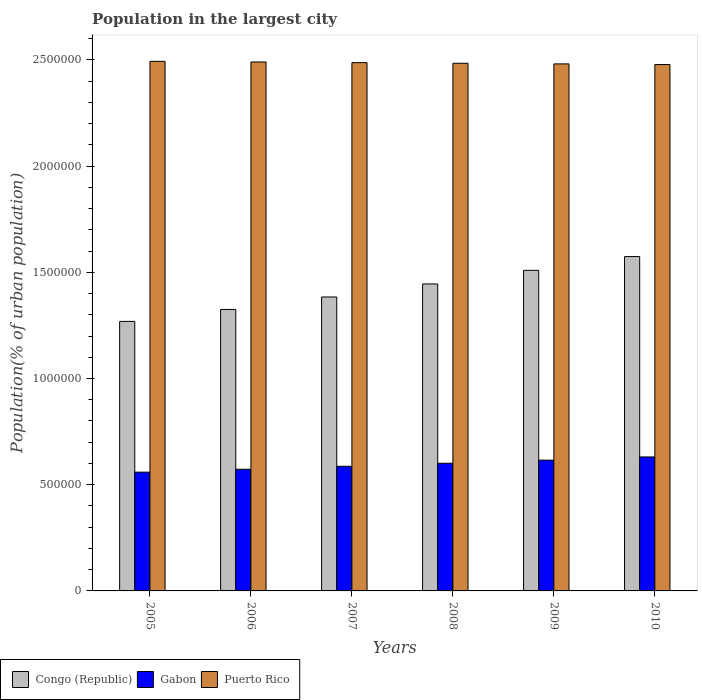How many different coloured bars are there?
Provide a succinct answer. 3. Are the number of bars on each tick of the X-axis equal?
Offer a very short reply. Yes. How many bars are there on the 3rd tick from the right?
Give a very brief answer. 3. In how many cases, is the number of bars for a given year not equal to the number of legend labels?
Ensure brevity in your answer.  0. What is the population in the largest city in Gabon in 2009?
Offer a very short reply. 6.16e+05. Across all years, what is the maximum population in the largest city in Congo (Republic)?
Your response must be concise. 1.57e+06. Across all years, what is the minimum population in the largest city in Congo (Republic)?
Provide a short and direct response. 1.27e+06. What is the total population in the largest city in Gabon in the graph?
Offer a terse response. 3.57e+06. What is the difference between the population in the largest city in Gabon in 2009 and that in 2010?
Your answer should be compact. -1.50e+04. What is the difference between the population in the largest city in Gabon in 2005 and the population in the largest city in Congo (Republic) in 2006?
Your answer should be compact. -7.66e+05. What is the average population in the largest city in Gabon per year?
Provide a succinct answer. 5.94e+05. In the year 2008, what is the difference between the population in the largest city in Gabon and population in the largest city in Congo (Republic)?
Ensure brevity in your answer.  -8.44e+05. What is the ratio of the population in the largest city in Gabon in 2005 to that in 2009?
Ensure brevity in your answer.  0.91. Is the difference between the population in the largest city in Gabon in 2007 and 2009 greater than the difference between the population in the largest city in Congo (Republic) in 2007 and 2009?
Provide a short and direct response. Yes. What is the difference between the highest and the second highest population in the largest city in Congo (Republic)?
Offer a very short reply. 6.49e+04. What is the difference between the highest and the lowest population in the largest city in Congo (Republic)?
Your answer should be very brief. 3.05e+05. What does the 3rd bar from the left in 2005 represents?
Offer a terse response. Puerto Rico. What does the 1st bar from the right in 2009 represents?
Offer a terse response. Puerto Rico. Is it the case that in every year, the sum of the population in the largest city in Congo (Republic) and population in the largest city in Puerto Rico is greater than the population in the largest city in Gabon?
Keep it short and to the point. Yes. Are all the bars in the graph horizontal?
Offer a terse response. No. What is the difference between two consecutive major ticks on the Y-axis?
Offer a very short reply. 5.00e+05. Are the values on the major ticks of Y-axis written in scientific E-notation?
Ensure brevity in your answer.  No. How are the legend labels stacked?
Give a very brief answer. Horizontal. What is the title of the graph?
Your answer should be compact. Population in the largest city. Does "Timor-Leste" appear as one of the legend labels in the graph?
Provide a short and direct response. No. What is the label or title of the X-axis?
Your answer should be compact. Years. What is the label or title of the Y-axis?
Give a very brief answer. Population(% of urban population). What is the Population(% of urban population) of Congo (Republic) in 2005?
Ensure brevity in your answer.  1.27e+06. What is the Population(% of urban population) in Gabon in 2005?
Make the answer very short. 5.59e+05. What is the Population(% of urban population) of Puerto Rico in 2005?
Your answer should be compact. 2.49e+06. What is the Population(% of urban population) in Congo (Republic) in 2006?
Give a very brief answer. 1.33e+06. What is the Population(% of urban population) in Gabon in 2006?
Offer a very short reply. 5.73e+05. What is the Population(% of urban population) in Puerto Rico in 2006?
Make the answer very short. 2.49e+06. What is the Population(% of urban population) of Congo (Republic) in 2007?
Make the answer very short. 1.38e+06. What is the Population(% of urban population) of Gabon in 2007?
Your response must be concise. 5.87e+05. What is the Population(% of urban population) in Puerto Rico in 2007?
Offer a terse response. 2.49e+06. What is the Population(% of urban population) in Congo (Republic) in 2008?
Make the answer very short. 1.45e+06. What is the Population(% of urban population) of Gabon in 2008?
Your answer should be compact. 6.01e+05. What is the Population(% of urban population) of Puerto Rico in 2008?
Your response must be concise. 2.48e+06. What is the Population(% of urban population) of Congo (Republic) in 2009?
Your answer should be very brief. 1.51e+06. What is the Population(% of urban population) of Gabon in 2009?
Your response must be concise. 6.16e+05. What is the Population(% of urban population) of Puerto Rico in 2009?
Make the answer very short. 2.48e+06. What is the Population(% of urban population) of Congo (Republic) in 2010?
Ensure brevity in your answer.  1.57e+06. What is the Population(% of urban population) of Gabon in 2010?
Give a very brief answer. 6.31e+05. What is the Population(% of urban population) of Puerto Rico in 2010?
Keep it short and to the point. 2.48e+06. Across all years, what is the maximum Population(% of urban population) in Congo (Republic)?
Provide a succinct answer. 1.57e+06. Across all years, what is the maximum Population(% of urban population) in Gabon?
Your response must be concise. 6.31e+05. Across all years, what is the maximum Population(% of urban population) of Puerto Rico?
Your answer should be very brief. 2.49e+06. Across all years, what is the minimum Population(% of urban population) in Congo (Republic)?
Ensure brevity in your answer.  1.27e+06. Across all years, what is the minimum Population(% of urban population) of Gabon?
Offer a terse response. 5.59e+05. Across all years, what is the minimum Population(% of urban population) in Puerto Rico?
Provide a short and direct response. 2.48e+06. What is the total Population(% of urban population) of Congo (Republic) in the graph?
Your answer should be compact. 8.51e+06. What is the total Population(% of urban population) in Gabon in the graph?
Offer a terse response. 3.57e+06. What is the total Population(% of urban population) of Puerto Rico in the graph?
Your answer should be very brief. 1.49e+07. What is the difference between the Population(% of urban population) of Congo (Republic) in 2005 and that in 2006?
Keep it short and to the point. -5.62e+04. What is the difference between the Population(% of urban population) in Gabon in 2005 and that in 2006?
Offer a terse response. -1.36e+04. What is the difference between the Population(% of urban population) of Puerto Rico in 2005 and that in 2006?
Give a very brief answer. 3008. What is the difference between the Population(% of urban population) of Congo (Republic) in 2005 and that in 2007?
Offer a terse response. -1.15e+05. What is the difference between the Population(% of urban population) in Gabon in 2005 and that in 2007?
Provide a succinct answer. -2.76e+04. What is the difference between the Population(% of urban population) in Puerto Rico in 2005 and that in 2007?
Ensure brevity in your answer.  6012. What is the difference between the Population(% of urban population) of Congo (Republic) in 2005 and that in 2008?
Provide a succinct answer. -1.76e+05. What is the difference between the Population(% of urban population) of Gabon in 2005 and that in 2008?
Provide a succinct answer. -4.19e+04. What is the difference between the Population(% of urban population) of Puerto Rico in 2005 and that in 2008?
Provide a succinct answer. 9017. What is the difference between the Population(% of urban population) of Congo (Republic) in 2005 and that in 2009?
Give a very brief answer. -2.40e+05. What is the difference between the Population(% of urban population) in Gabon in 2005 and that in 2009?
Provide a succinct answer. -5.66e+04. What is the difference between the Population(% of urban population) in Puerto Rico in 2005 and that in 2009?
Your response must be concise. 1.20e+04. What is the difference between the Population(% of urban population) in Congo (Republic) in 2005 and that in 2010?
Ensure brevity in your answer.  -3.05e+05. What is the difference between the Population(% of urban population) in Gabon in 2005 and that in 2010?
Your response must be concise. -7.16e+04. What is the difference between the Population(% of urban population) of Puerto Rico in 2005 and that in 2010?
Ensure brevity in your answer.  1.50e+04. What is the difference between the Population(% of urban population) in Congo (Republic) in 2006 and that in 2007?
Keep it short and to the point. -5.87e+04. What is the difference between the Population(% of urban population) in Gabon in 2006 and that in 2007?
Your response must be concise. -1.40e+04. What is the difference between the Population(% of urban population) of Puerto Rico in 2006 and that in 2007?
Offer a terse response. 3004. What is the difference between the Population(% of urban population) in Congo (Republic) in 2006 and that in 2008?
Your answer should be compact. -1.20e+05. What is the difference between the Population(% of urban population) of Gabon in 2006 and that in 2008?
Make the answer very short. -2.83e+04. What is the difference between the Population(% of urban population) in Puerto Rico in 2006 and that in 2008?
Your answer should be very brief. 6009. What is the difference between the Population(% of urban population) in Congo (Republic) in 2006 and that in 2009?
Offer a terse response. -1.84e+05. What is the difference between the Population(% of urban population) of Gabon in 2006 and that in 2009?
Offer a very short reply. -4.30e+04. What is the difference between the Population(% of urban population) in Puerto Rico in 2006 and that in 2009?
Offer a very short reply. 9002. What is the difference between the Population(% of urban population) in Congo (Republic) in 2006 and that in 2010?
Your answer should be compact. -2.49e+05. What is the difference between the Population(% of urban population) of Gabon in 2006 and that in 2010?
Offer a terse response. -5.80e+04. What is the difference between the Population(% of urban population) in Puerto Rico in 2006 and that in 2010?
Your answer should be compact. 1.20e+04. What is the difference between the Population(% of urban population) in Congo (Republic) in 2007 and that in 2008?
Provide a succinct answer. -6.13e+04. What is the difference between the Population(% of urban population) in Gabon in 2007 and that in 2008?
Offer a very short reply. -1.43e+04. What is the difference between the Population(% of urban population) of Puerto Rico in 2007 and that in 2008?
Keep it short and to the point. 3005. What is the difference between the Population(% of urban population) of Congo (Republic) in 2007 and that in 2009?
Your response must be concise. -1.25e+05. What is the difference between the Population(% of urban population) of Gabon in 2007 and that in 2009?
Give a very brief answer. -2.90e+04. What is the difference between the Population(% of urban population) in Puerto Rico in 2007 and that in 2009?
Make the answer very short. 5998. What is the difference between the Population(% of urban population) of Congo (Republic) in 2007 and that in 2010?
Ensure brevity in your answer.  -1.90e+05. What is the difference between the Population(% of urban population) in Gabon in 2007 and that in 2010?
Your answer should be very brief. -4.40e+04. What is the difference between the Population(% of urban population) in Puerto Rico in 2007 and that in 2010?
Offer a very short reply. 8992. What is the difference between the Population(% of urban population) of Congo (Republic) in 2008 and that in 2009?
Give a very brief answer. -6.40e+04. What is the difference between the Population(% of urban population) of Gabon in 2008 and that in 2009?
Make the answer very short. -1.47e+04. What is the difference between the Population(% of urban population) of Puerto Rico in 2008 and that in 2009?
Your response must be concise. 2993. What is the difference between the Population(% of urban population) in Congo (Republic) in 2008 and that in 2010?
Your answer should be compact. -1.29e+05. What is the difference between the Population(% of urban population) in Gabon in 2008 and that in 2010?
Your response must be concise. -2.97e+04. What is the difference between the Population(% of urban population) in Puerto Rico in 2008 and that in 2010?
Your response must be concise. 5987. What is the difference between the Population(% of urban population) of Congo (Republic) in 2009 and that in 2010?
Give a very brief answer. -6.49e+04. What is the difference between the Population(% of urban population) of Gabon in 2009 and that in 2010?
Offer a very short reply. -1.50e+04. What is the difference between the Population(% of urban population) in Puerto Rico in 2009 and that in 2010?
Make the answer very short. 2994. What is the difference between the Population(% of urban population) of Congo (Republic) in 2005 and the Population(% of urban population) of Gabon in 2006?
Offer a terse response. 6.96e+05. What is the difference between the Population(% of urban population) in Congo (Republic) in 2005 and the Population(% of urban population) in Puerto Rico in 2006?
Provide a succinct answer. -1.22e+06. What is the difference between the Population(% of urban population) in Gabon in 2005 and the Population(% of urban population) in Puerto Rico in 2006?
Your response must be concise. -1.93e+06. What is the difference between the Population(% of urban population) of Congo (Republic) in 2005 and the Population(% of urban population) of Gabon in 2007?
Provide a short and direct response. 6.82e+05. What is the difference between the Population(% of urban population) in Congo (Republic) in 2005 and the Population(% of urban population) in Puerto Rico in 2007?
Make the answer very short. -1.22e+06. What is the difference between the Population(% of urban population) in Gabon in 2005 and the Population(% of urban population) in Puerto Rico in 2007?
Provide a succinct answer. -1.93e+06. What is the difference between the Population(% of urban population) of Congo (Republic) in 2005 and the Population(% of urban population) of Gabon in 2008?
Give a very brief answer. 6.68e+05. What is the difference between the Population(% of urban population) in Congo (Republic) in 2005 and the Population(% of urban population) in Puerto Rico in 2008?
Your response must be concise. -1.22e+06. What is the difference between the Population(% of urban population) of Gabon in 2005 and the Population(% of urban population) of Puerto Rico in 2008?
Make the answer very short. -1.93e+06. What is the difference between the Population(% of urban population) of Congo (Republic) in 2005 and the Population(% of urban population) of Gabon in 2009?
Offer a very short reply. 6.53e+05. What is the difference between the Population(% of urban population) in Congo (Republic) in 2005 and the Population(% of urban population) in Puerto Rico in 2009?
Your answer should be compact. -1.21e+06. What is the difference between the Population(% of urban population) in Gabon in 2005 and the Population(% of urban population) in Puerto Rico in 2009?
Offer a terse response. -1.92e+06. What is the difference between the Population(% of urban population) of Congo (Republic) in 2005 and the Population(% of urban population) of Gabon in 2010?
Your answer should be very brief. 6.38e+05. What is the difference between the Population(% of urban population) in Congo (Republic) in 2005 and the Population(% of urban population) in Puerto Rico in 2010?
Your response must be concise. -1.21e+06. What is the difference between the Population(% of urban population) of Gabon in 2005 and the Population(% of urban population) of Puerto Rico in 2010?
Provide a succinct answer. -1.92e+06. What is the difference between the Population(% of urban population) in Congo (Republic) in 2006 and the Population(% of urban population) in Gabon in 2007?
Ensure brevity in your answer.  7.38e+05. What is the difference between the Population(% of urban population) of Congo (Republic) in 2006 and the Population(% of urban population) of Puerto Rico in 2007?
Your response must be concise. -1.16e+06. What is the difference between the Population(% of urban population) of Gabon in 2006 and the Population(% of urban population) of Puerto Rico in 2007?
Offer a terse response. -1.91e+06. What is the difference between the Population(% of urban population) of Congo (Republic) in 2006 and the Population(% of urban population) of Gabon in 2008?
Offer a terse response. 7.24e+05. What is the difference between the Population(% of urban population) of Congo (Republic) in 2006 and the Population(% of urban population) of Puerto Rico in 2008?
Ensure brevity in your answer.  -1.16e+06. What is the difference between the Population(% of urban population) in Gabon in 2006 and the Population(% of urban population) in Puerto Rico in 2008?
Make the answer very short. -1.91e+06. What is the difference between the Population(% of urban population) of Congo (Republic) in 2006 and the Population(% of urban population) of Gabon in 2009?
Give a very brief answer. 7.09e+05. What is the difference between the Population(% of urban population) in Congo (Republic) in 2006 and the Population(% of urban population) in Puerto Rico in 2009?
Offer a terse response. -1.16e+06. What is the difference between the Population(% of urban population) of Gabon in 2006 and the Population(% of urban population) of Puerto Rico in 2009?
Your answer should be very brief. -1.91e+06. What is the difference between the Population(% of urban population) in Congo (Republic) in 2006 and the Population(% of urban population) in Gabon in 2010?
Offer a terse response. 6.94e+05. What is the difference between the Population(% of urban population) of Congo (Republic) in 2006 and the Population(% of urban population) of Puerto Rico in 2010?
Provide a short and direct response. -1.15e+06. What is the difference between the Population(% of urban population) in Gabon in 2006 and the Population(% of urban population) in Puerto Rico in 2010?
Offer a terse response. -1.91e+06. What is the difference between the Population(% of urban population) of Congo (Republic) in 2007 and the Population(% of urban population) of Gabon in 2008?
Provide a short and direct response. 7.83e+05. What is the difference between the Population(% of urban population) of Congo (Republic) in 2007 and the Population(% of urban population) of Puerto Rico in 2008?
Ensure brevity in your answer.  -1.10e+06. What is the difference between the Population(% of urban population) in Gabon in 2007 and the Population(% of urban population) in Puerto Rico in 2008?
Provide a short and direct response. -1.90e+06. What is the difference between the Population(% of urban population) of Congo (Republic) in 2007 and the Population(% of urban population) of Gabon in 2009?
Provide a short and direct response. 7.68e+05. What is the difference between the Population(% of urban population) of Congo (Republic) in 2007 and the Population(% of urban population) of Puerto Rico in 2009?
Your answer should be very brief. -1.10e+06. What is the difference between the Population(% of urban population) of Gabon in 2007 and the Population(% of urban population) of Puerto Rico in 2009?
Make the answer very short. -1.89e+06. What is the difference between the Population(% of urban population) in Congo (Republic) in 2007 and the Population(% of urban population) in Gabon in 2010?
Provide a short and direct response. 7.53e+05. What is the difference between the Population(% of urban population) in Congo (Republic) in 2007 and the Population(% of urban population) in Puerto Rico in 2010?
Make the answer very short. -1.09e+06. What is the difference between the Population(% of urban population) in Gabon in 2007 and the Population(% of urban population) in Puerto Rico in 2010?
Offer a terse response. -1.89e+06. What is the difference between the Population(% of urban population) of Congo (Republic) in 2008 and the Population(% of urban population) of Gabon in 2009?
Provide a succinct answer. 8.29e+05. What is the difference between the Population(% of urban population) of Congo (Republic) in 2008 and the Population(% of urban population) of Puerto Rico in 2009?
Provide a short and direct response. -1.04e+06. What is the difference between the Population(% of urban population) of Gabon in 2008 and the Population(% of urban population) of Puerto Rico in 2009?
Your response must be concise. -1.88e+06. What is the difference between the Population(% of urban population) in Congo (Republic) in 2008 and the Population(% of urban population) in Gabon in 2010?
Offer a very short reply. 8.14e+05. What is the difference between the Population(% of urban population) in Congo (Republic) in 2008 and the Population(% of urban population) in Puerto Rico in 2010?
Your answer should be compact. -1.03e+06. What is the difference between the Population(% of urban population) of Gabon in 2008 and the Population(% of urban population) of Puerto Rico in 2010?
Your answer should be very brief. -1.88e+06. What is the difference between the Population(% of urban population) of Congo (Republic) in 2009 and the Population(% of urban population) of Gabon in 2010?
Your response must be concise. 8.78e+05. What is the difference between the Population(% of urban population) of Congo (Republic) in 2009 and the Population(% of urban population) of Puerto Rico in 2010?
Offer a terse response. -9.69e+05. What is the difference between the Population(% of urban population) in Gabon in 2009 and the Population(% of urban population) in Puerto Rico in 2010?
Ensure brevity in your answer.  -1.86e+06. What is the average Population(% of urban population) in Congo (Republic) per year?
Your answer should be very brief. 1.42e+06. What is the average Population(% of urban population) of Gabon per year?
Your answer should be compact. 5.94e+05. What is the average Population(% of urban population) of Puerto Rico per year?
Your answer should be compact. 2.49e+06. In the year 2005, what is the difference between the Population(% of urban population) of Congo (Republic) and Population(% of urban population) of Gabon?
Make the answer very short. 7.10e+05. In the year 2005, what is the difference between the Population(% of urban population) of Congo (Republic) and Population(% of urban population) of Puerto Rico?
Keep it short and to the point. -1.22e+06. In the year 2005, what is the difference between the Population(% of urban population) of Gabon and Population(% of urban population) of Puerto Rico?
Keep it short and to the point. -1.93e+06. In the year 2006, what is the difference between the Population(% of urban population) of Congo (Republic) and Population(% of urban population) of Gabon?
Provide a succinct answer. 7.52e+05. In the year 2006, what is the difference between the Population(% of urban population) in Congo (Republic) and Population(% of urban population) in Puerto Rico?
Keep it short and to the point. -1.17e+06. In the year 2006, what is the difference between the Population(% of urban population) in Gabon and Population(% of urban population) in Puerto Rico?
Offer a terse response. -1.92e+06. In the year 2007, what is the difference between the Population(% of urban population) of Congo (Republic) and Population(% of urban population) of Gabon?
Give a very brief answer. 7.97e+05. In the year 2007, what is the difference between the Population(% of urban population) in Congo (Republic) and Population(% of urban population) in Puerto Rico?
Your answer should be compact. -1.10e+06. In the year 2007, what is the difference between the Population(% of urban population) of Gabon and Population(% of urban population) of Puerto Rico?
Keep it short and to the point. -1.90e+06. In the year 2008, what is the difference between the Population(% of urban population) of Congo (Republic) and Population(% of urban population) of Gabon?
Your answer should be compact. 8.44e+05. In the year 2008, what is the difference between the Population(% of urban population) of Congo (Republic) and Population(% of urban population) of Puerto Rico?
Make the answer very short. -1.04e+06. In the year 2008, what is the difference between the Population(% of urban population) of Gabon and Population(% of urban population) of Puerto Rico?
Offer a terse response. -1.88e+06. In the year 2009, what is the difference between the Population(% of urban population) in Congo (Republic) and Population(% of urban population) in Gabon?
Ensure brevity in your answer.  8.94e+05. In the year 2009, what is the difference between the Population(% of urban population) in Congo (Republic) and Population(% of urban population) in Puerto Rico?
Your answer should be very brief. -9.72e+05. In the year 2009, what is the difference between the Population(% of urban population) in Gabon and Population(% of urban population) in Puerto Rico?
Make the answer very short. -1.87e+06. In the year 2010, what is the difference between the Population(% of urban population) in Congo (Republic) and Population(% of urban population) in Gabon?
Provide a short and direct response. 9.43e+05. In the year 2010, what is the difference between the Population(% of urban population) in Congo (Republic) and Population(% of urban population) in Puerto Rico?
Offer a very short reply. -9.04e+05. In the year 2010, what is the difference between the Population(% of urban population) of Gabon and Population(% of urban population) of Puerto Rico?
Offer a very short reply. -1.85e+06. What is the ratio of the Population(% of urban population) of Congo (Republic) in 2005 to that in 2006?
Make the answer very short. 0.96. What is the ratio of the Population(% of urban population) in Gabon in 2005 to that in 2006?
Your answer should be compact. 0.98. What is the ratio of the Population(% of urban population) in Puerto Rico in 2005 to that in 2006?
Provide a short and direct response. 1. What is the ratio of the Population(% of urban population) of Congo (Republic) in 2005 to that in 2007?
Give a very brief answer. 0.92. What is the ratio of the Population(% of urban population) in Gabon in 2005 to that in 2007?
Give a very brief answer. 0.95. What is the ratio of the Population(% of urban population) in Puerto Rico in 2005 to that in 2007?
Your response must be concise. 1. What is the ratio of the Population(% of urban population) of Congo (Republic) in 2005 to that in 2008?
Ensure brevity in your answer.  0.88. What is the ratio of the Population(% of urban population) in Gabon in 2005 to that in 2008?
Provide a short and direct response. 0.93. What is the ratio of the Population(% of urban population) of Congo (Republic) in 2005 to that in 2009?
Provide a succinct answer. 0.84. What is the ratio of the Population(% of urban population) in Gabon in 2005 to that in 2009?
Provide a succinct answer. 0.91. What is the ratio of the Population(% of urban population) of Congo (Republic) in 2005 to that in 2010?
Your response must be concise. 0.81. What is the ratio of the Population(% of urban population) in Gabon in 2005 to that in 2010?
Offer a terse response. 0.89. What is the ratio of the Population(% of urban population) in Congo (Republic) in 2006 to that in 2007?
Your response must be concise. 0.96. What is the ratio of the Population(% of urban population) of Gabon in 2006 to that in 2007?
Your answer should be very brief. 0.98. What is the ratio of the Population(% of urban population) of Congo (Republic) in 2006 to that in 2008?
Provide a succinct answer. 0.92. What is the ratio of the Population(% of urban population) in Gabon in 2006 to that in 2008?
Ensure brevity in your answer.  0.95. What is the ratio of the Population(% of urban population) in Congo (Republic) in 2006 to that in 2009?
Keep it short and to the point. 0.88. What is the ratio of the Population(% of urban population) in Gabon in 2006 to that in 2009?
Offer a terse response. 0.93. What is the ratio of the Population(% of urban population) of Puerto Rico in 2006 to that in 2009?
Your answer should be compact. 1. What is the ratio of the Population(% of urban population) of Congo (Republic) in 2006 to that in 2010?
Your response must be concise. 0.84. What is the ratio of the Population(% of urban population) in Gabon in 2006 to that in 2010?
Provide a succinct answer. 0.91. What is the ratio of the Population(% of urban population) in Congo (Republic) in 2007 to that in 2008?
Make the answer very short. 0.96. What is the ratio of the Population(% of urban population) of Gabon in 2007 to that in 2008?
Ensure brevity in your answer.  0.98. What is the ratio of the Population(% of urban population) in Puerto Rico in 2007 to that in 2008?
Ensure brevity in your answer.  1. What is the ratio of the Population(% of urban population) of Congo (Republic) in 2007 to that in 2009?
Provide a succinct answer. 0.92. What is the ratio of the Population(% of urban population) of Gabon in 2007 to that in 2009?
Offer a terse response. 0.95. What is the ratio of the Population(% of urban population) of Puerto Rico in 2007 to that in 2009?
Your response must be concise. 1. What is the ratio of the Population(% of urban population) of Congo (Republic) in 2007 to that in 2010?
Provide a succinct answer. 0.88. What is the ratio of the Population(% of urban population) in Gabon in 2007 to that in 2010?
Your answer should be very brief. 0.93. What is the ratio of the Population(% of urban population) in Puerto Rico in 2007 to that in 2010?
Your response must be concise. 1. What is the ratio of the Population(% of urban population) of Congo (Republic) in 2008 to that in 2009?
Make the answer very short. 0.96. What is the ratio of the Population(% of urban population) of Gabon in 2008 to that in 2009?
Give a very brief answer. 0.98. What is the ratio of the Population(% of urban population) of Congo (Republic) in 2008 to that in 2010?
Ensure brevity in your answer.  0.92. What is the ratio of the Population(% of urban population) in Gabon in 2008 to that in 2010?
Provide a short and direct response. 0.95. What is the ratio of the Population(% of urban population) in Congo (Republic) in 2009 to that in 2010?
Provide a succinct answer. 0.96. What is the ratio of the Population(% of urban population) of Gabon in 2009 to that in 2010?
Offer a terse response. 0.98. What is the difference between the highest and the second highest Population(% of urban population) of Congo (Republic)?
Your answer should be compact. 6.49e+04. What is the difference between the highest and the second highest Population(% of urban population) of Gabon?
Keep it short and to the point. 1.50e+04. What is the difference between the highest and the second highest Population(% of urban population) of Puerto Rico?
Your answer should be compact. 3008. What is the difference between the highest and the lowest Population(% of urban population) of Congo (Republic)?
Give a very brief answer. 3.05e+05. What is the difference between the highest and the lowest Population(% of urban population) of Gabon?
Offer a terse response. 7.16e+04. What is the difference between the highest and the lowest Population(% of urban population) of Puerto Rico?
Give a very brief answer. 1.50e+04. 